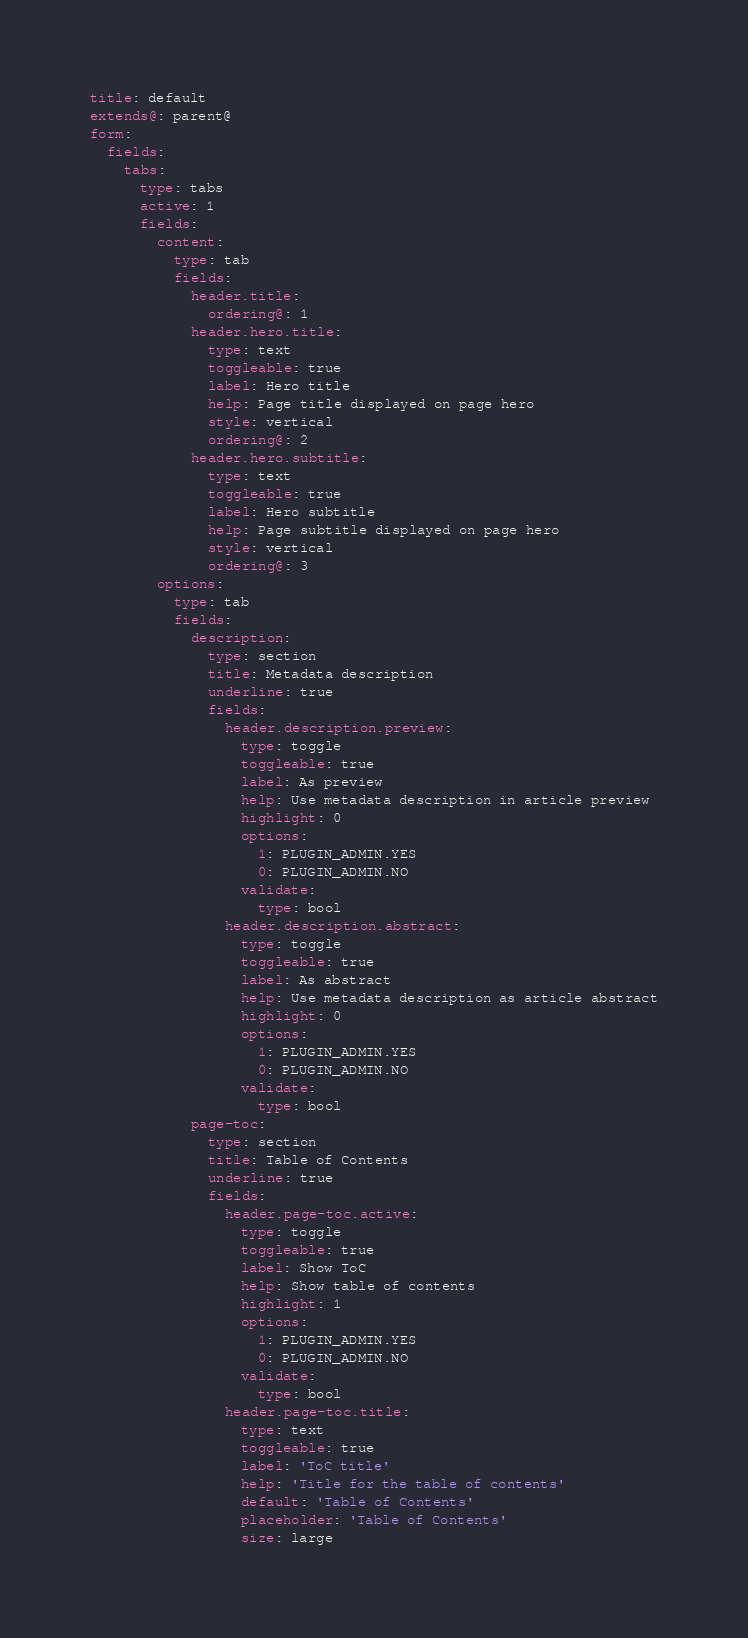<code> <loc_0><loc_0><loc_500><loc_500><_YAML_>title: default
extends@: parent@
form:
  fields:
    tabs:
      type: tabs
      active: 1
      fields:
        content:
          type: tab
          fields:
            header.title:
              ordering@: 1
            header.hero.title:
              type: text
              toggleable: true
              label: Hero title
              help: Page title displayed on page hero
              style: vertical
              ordering@: 2
            header.hero.subtitle:
              type: text
              toggleable: true
              label: Hero subtitle
              help: Page subtitle displayed on page hero
              style: vertical
              ordering@: 3
        options:
          type: tab
          fields:
            description:
              type: section
              title: Metadata description
              underline: true
              fields:
                header.description.preview:
                  type: toggle
                  toggleable: true
                  label: As preview
                  help: Use metadata description in article preview
                  highlight: 0
                  options:
                    1: PLUGIN_ADMIN.YES
                    0: PLUGIN_ADMIN.NO
                  validate:
                    type: bool
                header.description.abstract:
                  type: toggle
                  toggleable: true
                  label: As abstract
                  help: Use metadata description as article abstract
                  highlight: 0
                  options:
                    1: PLUGIN_ADMIN.YES
                    0: PLUGIN_ADMIN.NO
                  validate:
                    type: bool
            page-toc:
              type: section
              title: Table of Contents
              underline: true
              fields:
                header.page-toc.active:
                  type: toggle
                  toggleable: true
                  label: Show ToC
                  help: Show table of contents
                  highlight: 1
                  options:
                    1: PLUGIN_ADMIN.YES
                    0: PLUGIN_ADMIN.NO
                  validate:
                    type: bool
                header.page-toc.title:
                  type: text
                  toggleable: true
                  label: 'ToC title'
                  help: 'Title for the table of contents'
                  default: 'Table of Contents'
                  placeholder: 'Table of Contents'
                  size: large
</code> 